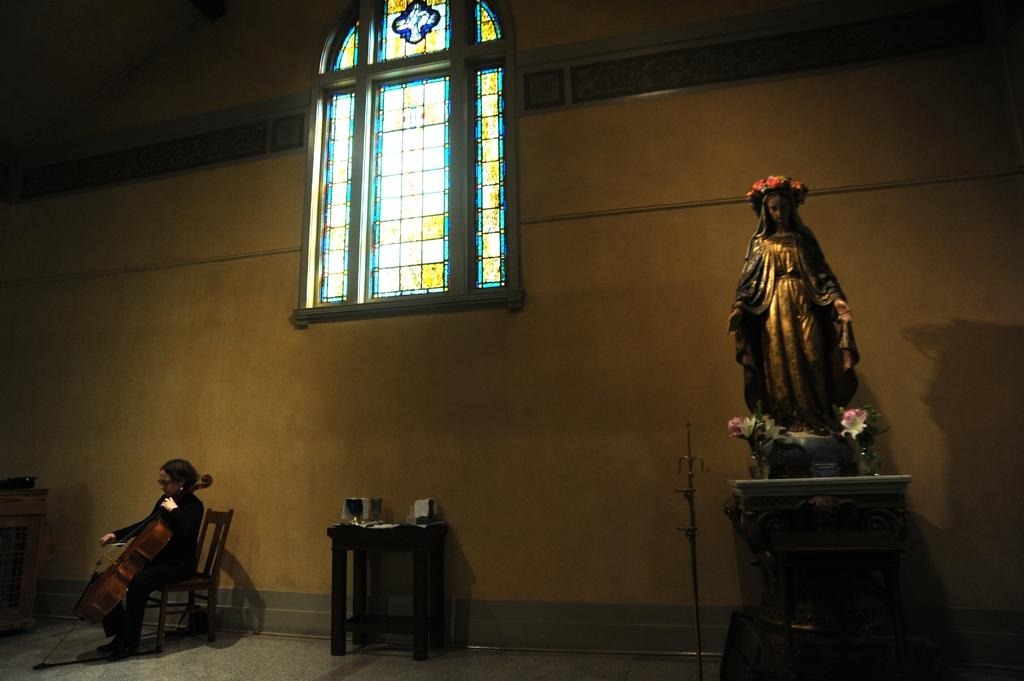What is the main subject in the image? There is a statue in the image. Can you describe the woman in the image? There is a woman seated on a chair in the image. What is the woman doing in the image? The woman is playing a violin in the image. Can you see a squirrel biting the statue in the image? There is no squirrel present in the image, and therefore no such activity can be observed. 